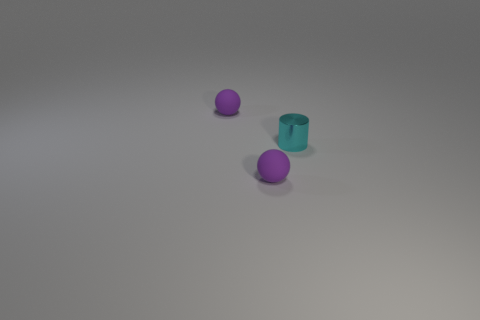The small matte thing behind the rubber ball that is in front of the shiny thing is what shape?
Make the answer very short. Sphere. What is the size of the ball in front of the tiny cyan cylinder that is behind the tiny rubber thing that is in front of the tiny cyan thing?
Keep it short and to the point. Small. What is the material of the tiny purple object in front of the tiny cyan thing?
Your answer should be very brief. Rubber. How many other things are the same shape as the tiny cyan metal object?
Provide a short and direct response. 0. There is a cyan shiny cylinder; are there any purple matte objects in front of it?
Give a very brief answer. Yes. How many things are either tiny purple rubber objects or small cyan metal objects?
Offer a terse response. 3. How many objects are either purple balls behind the tiny metal object or rubber balls in front of the cyan shiny thing?
Offer a very short reply. 2. Is the number of tiny rubber balls behind the tiny cyan metallic thing greater than the number of green blocks?
Your answer should be very brief. Yes. What number of things are small purple matte spheres that are behind the tiny metal cylinder or large green objects?
Give a very brief answer. 1. How many cylinders are on the right side of the purple matte thing that is behind the small cylinder?
Provide a short and direct response. 1. 